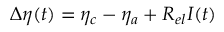<formula> <loc_0><loc_0><loc_500><loc_500>\Delta { \eta } ( t ) = { \eta } _ { c } - { \eta } _ { a } + { R } _ { e l } I ( t )</formula> 